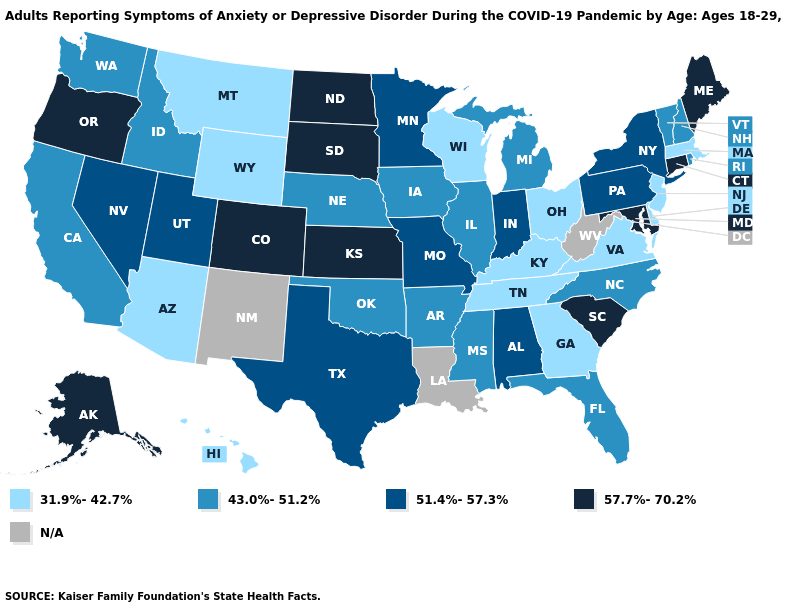What is the highest value in states that border North Dakota?
Be succinct. 57.7%-70.2%. Name the states that have a value in the range 31.9%-42.7%?
Short answer required. Arizona, Delaware, Georgia, Hawaii, Kentucky, Massachusetts, Montana, New Jersey, Ohio, Tennessee, Virginia, Wisconsin, Wyoming. Name the states that have a value in the range 43.0%-51.2%?
Keep it brief. Arkansas, California, Florida, Idaho, Illinois, Iowa, Michigan, Mississippi, Nebraska, New Hampshire, North Carolina, Oklahoma, Rhode Island, Vermont, Washington. Does the map have missing data?
Give a very brief answer. Yes. Name the states that have a value in the range 57.7%-70.2%?
Write a very short answer. Alaska, Colorado, Connecticut, Kansas, Maine, Maryland, North Dakota, Oregon, South Carolina, South Dakota. Name the states that have a value in the range 43.0%-51.2%?
Give a very brief answer. Arkansas, California, Florida, Idaho, Illinois, Iowa, Michigan, Mississippi, Nebraska, New Hampshire, North Carolina, Oklahoma, Rhode Island, Vermont, Washington. Name the states that have a value in the range 57.7%-70.2%?
Keep it brief. Alaska, Colorado, Connecticut, Kansas, Maine, Maryland, North Dakota, Oregon, South Carolina, South Dakota. Which states have the lowest value in the USA?
Write a very short answer. Arizona, Delaware, Georgia, Hawaii, Kentucky, Massachusetts, Montana, New Jersey, Ohio, Tennessee, Virginia, Wisconsin, Wyoming. How many symbols are there in the legend?
Give a very brief answer. 5. Does the map have missing data?
Concise answer only. Yes. What is the value of Oklahoma?
Write a very short answer. 43.0%-51.2%. What is the value of New Mexico?
Write a very short answer. N/A. What is the value of Iowa?
Give a very brief answer. 43.0%-51.2%. Which states hav the highest value in the Northeast?
Quick response, please. Connecticut, Maine. 